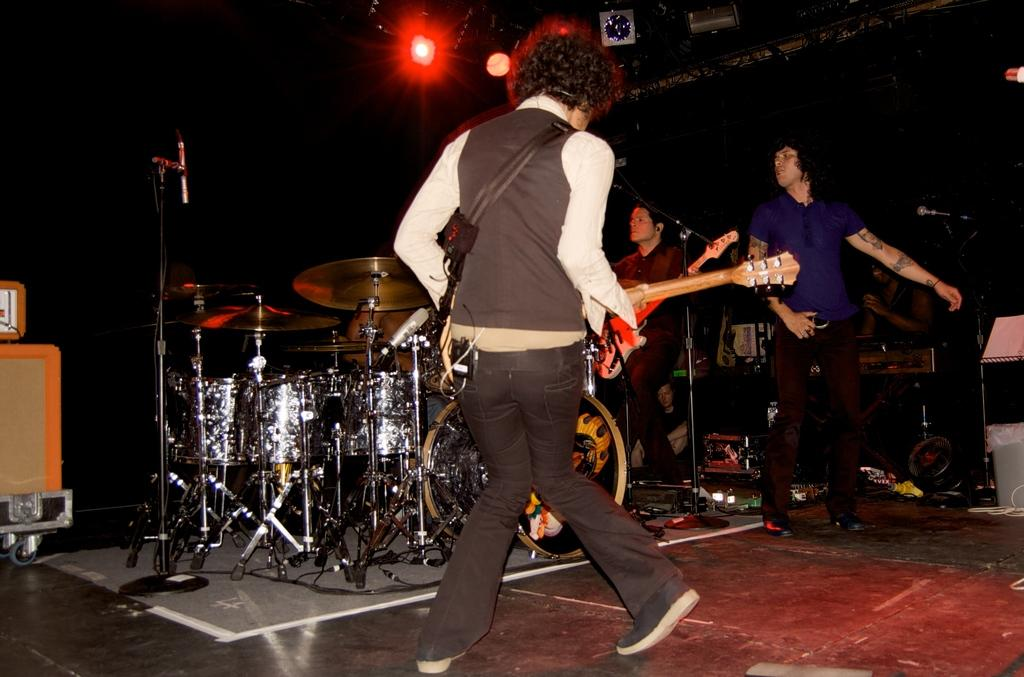How many people are present in the image? There are four people in the image. What are two of the people doing in the image? Two of the people are holding musical instruments. What can be seen on the stage in the image? There is a drum set on the stage. What is visible in the background of the image? There is a light in the background of the image. What type of fairies can be seen dancing around the drum set in the image? There are no fairies present in the image; it features four people and a drum set on the stage. What is the opinion of the horses about the musical performance in the image? There are no horses present in the image, so it is not possible to determine their opinion about the musical performance. 